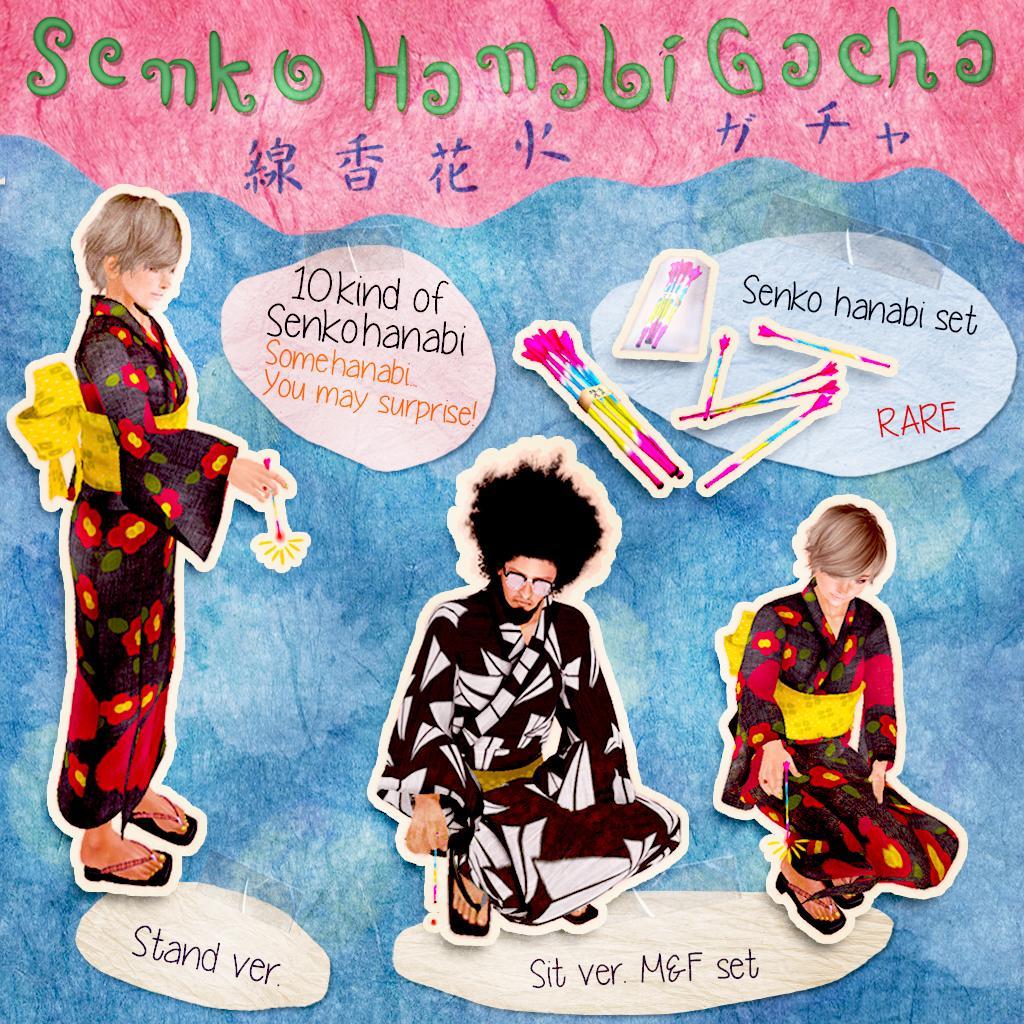Please provide a concise description of this image. It is a painting image. In the image in the center we can see three persons stickers were passed on the painting. And we can see something written on the painting. 